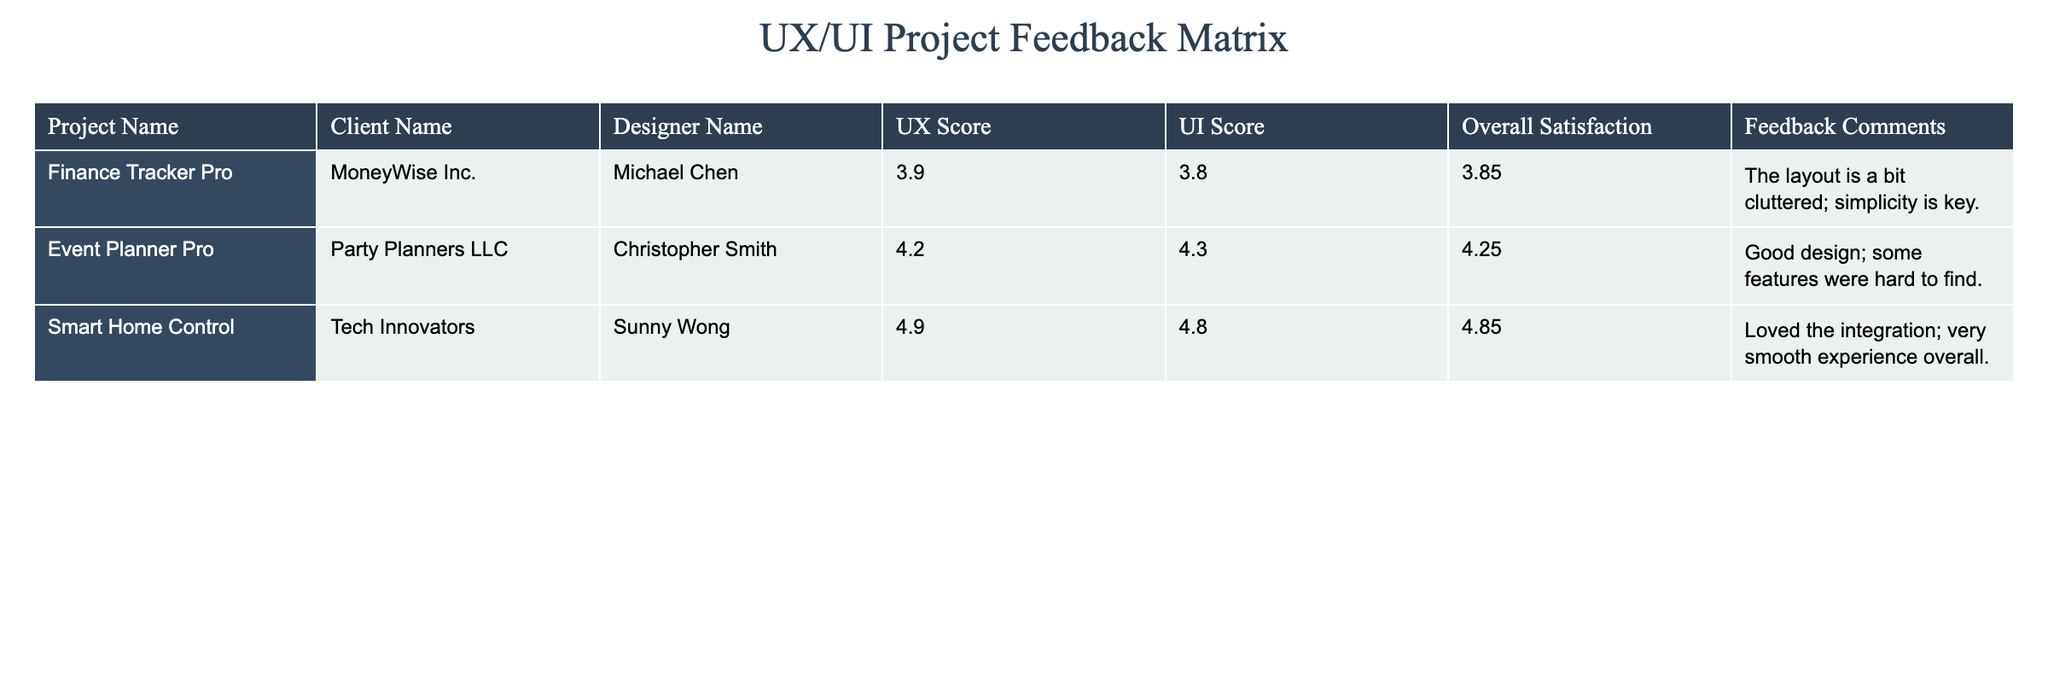What's the UX score for the "Smart Home Control" project? The UX score for the "Smart Home Control" project is found in the corresponding column for that project, which lists the score as "4.9".
Answer: 4.9 What are the feedback comments for "Event Planner Pro"? The feedback comments for "Event Planner Pro" can be read directly in the table. The comments state, "Good design; some features were hard to find."
Answer: Good design; some features were hard to find Which project had the highest overall satisfaction rating? By looking at the "Overall Satisfaction" column, "Smart Home Control" has the highest score at "4.85", higher than the other projects.
Answer: Smart Home Control Is the UI score for "Finance Tracker Pro" greater than 4? The UI score for "Finance Tracker Pro" is "3.8", which is less than 4. Thus, the statement is false.
Answer: No What is the average UI score across all three projects? To find the average UI score, add the scores together (3.8 + 4.3 + 4.8 = 12.9) and divide by the number of projects (3). Therefore, the average is 12.9 / 3 = 4.3.
Answer: 4.3 Do all projects have an overall satisfaction rating of at least 4? By checking the "Overall Satisfaction" scores, two projects meet or exceed a score of 4, while "Finance Tracker Pro" has a score of "3.85," which is less than 4. Hence, not all satisfy this condition.
Answer: No What is the difference between the UX score of "Smart Home Control" and "Finance Tracker Pro"? To calculate the difference, subtract the UX score of "Finance Tracker Pro" (3.9) from "Smart Home Control" (4.9). Thus, 4.9 - 3.9 = 1.0.
Answer: 1.0 Which client's project received the most positive feedback based on comments? Reading through the feedback comments, "Smart Home Control" received comments like "Loved the integration; very smooth experience overall," indicating the most positive sentiment among all projects.
Answer: Smart Home Control How many projects received a UI score of less than 4? From the table, only "Finance Tracker Pro" has a UI score of "3.8," less than 4. This means only one project falls into this category.
Answer: 1 